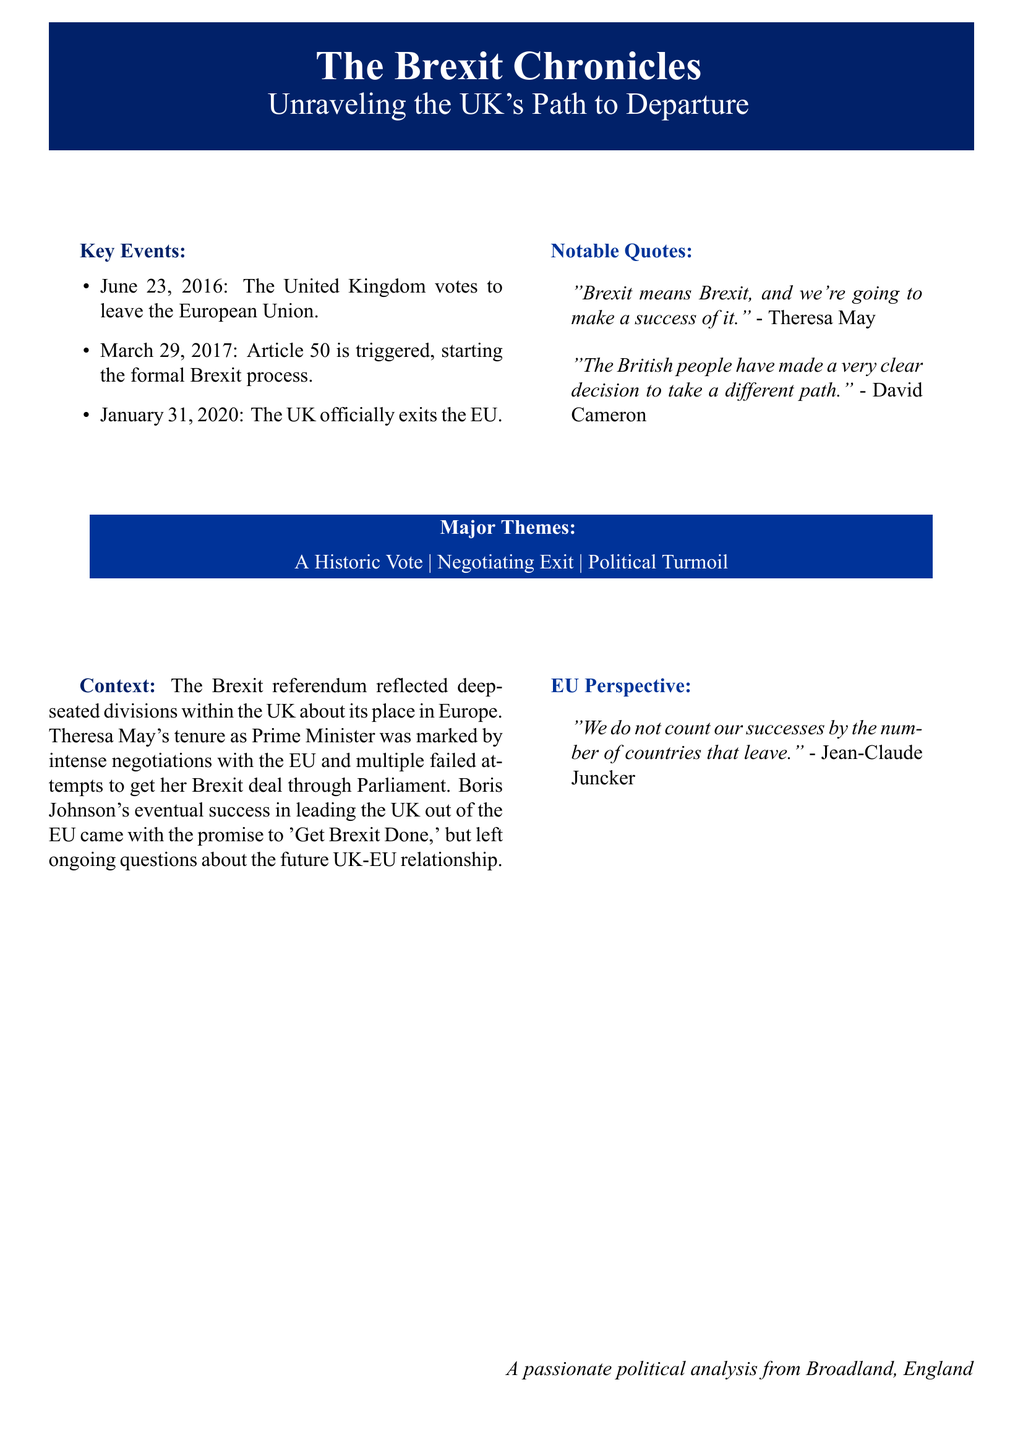What is the title of the book? The title of the book is prominently displayed in the center of the cover.
Answer: The Brexit Chronicles When did the UK vote to leave the EU? The cover lists the date of the vote as one of the key events.
Answer: June 23, 2016 Who was the Prime Minister when Article 50 was triggered? The document mentions key events, including the triggering of Article 50 under a specific Prime Minister.
Answer: Theresa May What is one of the major themes mentioned on the cover? The document highlights major themes related to Brexit in a dedicated section.
Answer: Political Turmoil Who said, "Brexit means Brexit, and we're going to make a success of it"? The notable quotes section attributes this statement to a specific political figure.
Answer: Theresa May What color is used for the background of the title box? The color used for the title box can be observed directly from the design.
Answer: Union Jack Blue What was Boris Johnson's promise regarding Brexit? The context section includes critical statements regarding Boris Johnson's stance during the Brexit process.
Answer: Get Brexit Done What quote reflects the EU's perspective on member states leaving? A quote in the EU perspective section directly addresses this sentiment.
Answer: "We do not count our successes by the number of countries that leave." 